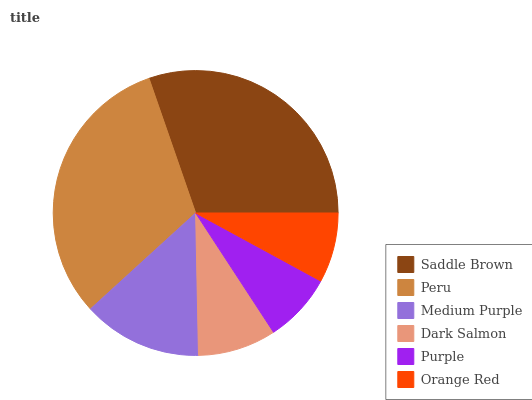Is Purple the minimum?
Answer yes or no. Yes. Is Peru the maximum?
Answer yes or no. Yes. Is Medium Purple the minimum?
Answer yes or no. No. Is Medium Purple the maximum?
Answer yes or no. No. Is Peru greater than Medium Purple?
Answer yes or no. Yes. Is Medium Purple less than Peru?
Answer yes or no. Yes. Is Medium Purple greater than Peru?
Answer yes or no. No. Is Peru less than Medium Purple?
Answer yes or no. No. Is Medium Purple the high median?
Answer yes or no. Yes. Is Dark Salmon the low median?
Answer yes or no. Yes. Is Saddle Brown the high median?
Answer yes or no. No. Is Medium Purple the low median?
Answer yes or no. No. 